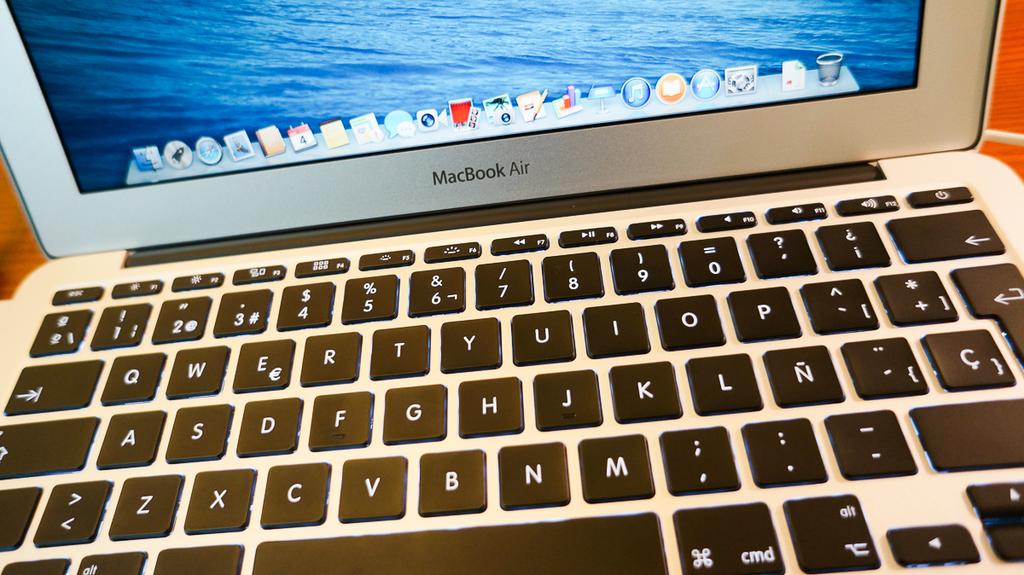What brand of laptop is this?
Keep it short and to the point. Macbook air. What type of keyboard is this?
Provide a succinct answer. Macbook air. 